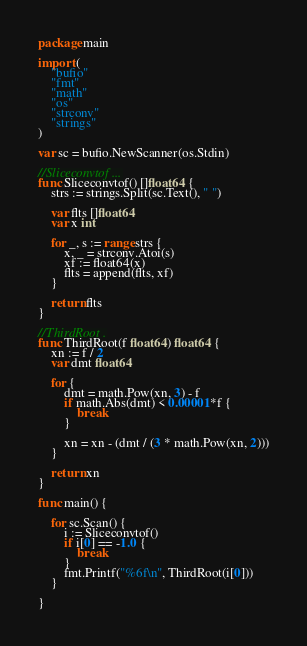<code> <loc_0><loc_0><loc_500><loc_500><_Go_>package main

import (
	"bufio"
	"fmt"
	"math"
	"os"
	"strconv"
	"strings"
)

var sc = bufio.NewScanner(os.Stdin)

//Sliceconvtof ...
func Sliceconvtof() []float64 {
	strs := strings.Split(sc.Text(), " ")

	var flts []float64
	var x int

	for _, s := range strs {
		x, _ = strconv.Atoi(s)
		xf := float64(x)
		flts = append(flts, xf)
	}

	return flts
}

//ThirdRoot .
func ThirdRoot(f float64) float64 {
	xn := f / 2
	var dmt float64

	for {
		dmt = math.Pow(xn, 3) - f
		if math.Abs(dmt) < 0.00001*f {
			break
		}

		xn = xn - (dmt / (3 * math.Pow(xn, 2)))
	}

	return xn
}

func main() {

	for sc.Scan() {
		i := Sliceconvtof()
		if i[0] == -1.0 {
			break
		}
		fmt.Printf("%6f\n", ThirdRoot(i[0]))
	}

}

</code> 